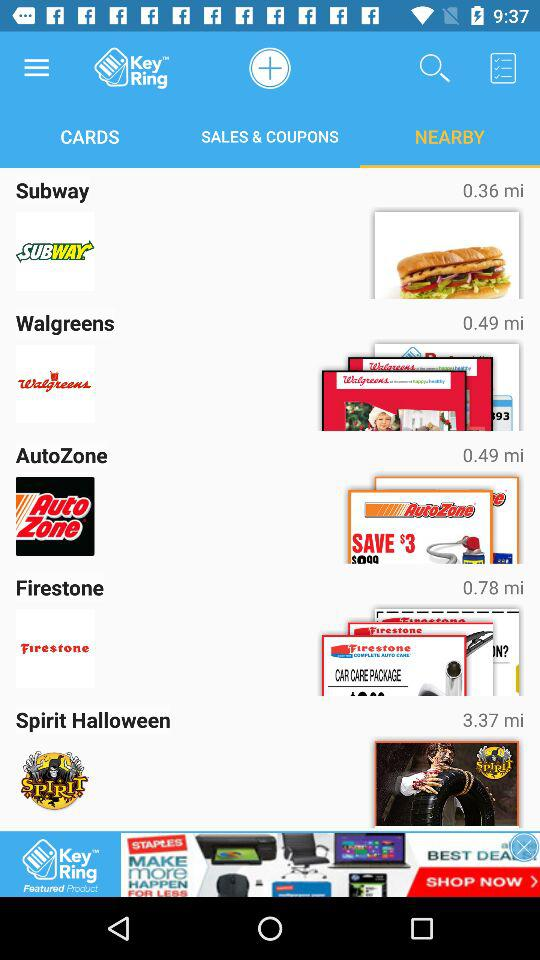What is the version of this application?
When the provided information is insufficient, respond with <no answer>. <no answer> 